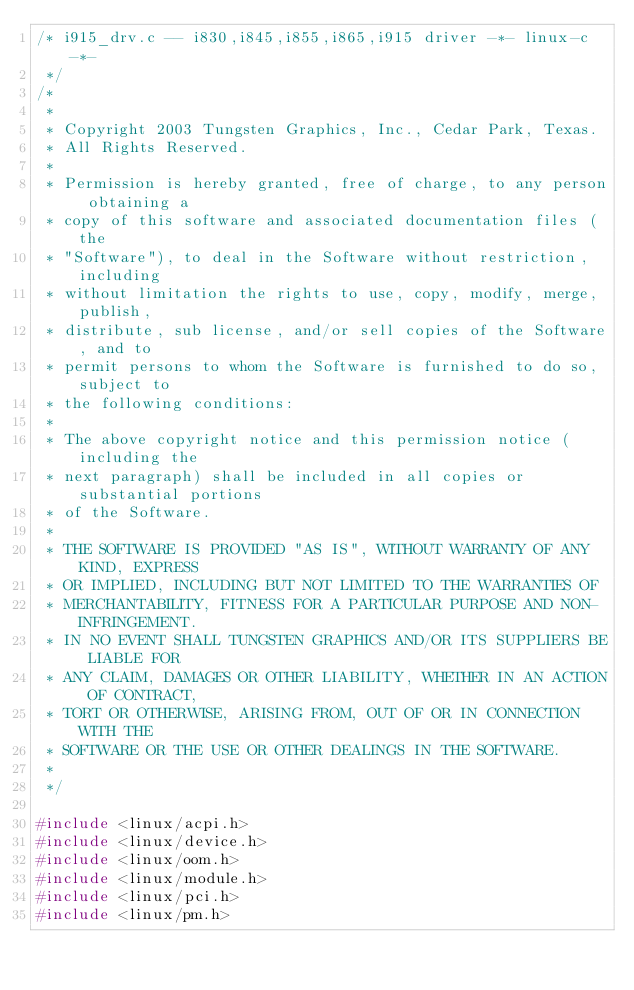Convert code to text. <code><loc_0><loc_0><loc_500><loc_500><_C_>/* i915_drv.c -- i830,i845,i855,i865,i915 driver -*- linux-c -*-
 */
/*
 *
 * Copyright 2003 Tungsten Graphics, Inc., Cedar Park, Texas.
 * All Rights Reserved.
 *
 * Permission is hereby granted, free of charge, to any person obtaining a
 * copy of this software and associated documentation files (the
 * "Software"), to deal in the Software without restriction, including
 * without limitation the rights to use, copy, modify, merge, publish,
 * distribute, sub license, and/or sell copies of the Software, and to
 * permit persons to whom the Software is furnished to do so, subject to
 * the following conditions:
 *
 * The above copyright notice and this permission notice (including the
 * next paragraph) shall be included in all copies or substantial portions
 * of the Software.
 *
 * THE SOFTWARE IS PROVIDED "AS IS", WITHOUT WARRANTY OF ANY KIND, EXPRESS
 * OR IMPLIED, INCLUDING BUT NOT LIMITED TO THE WARRANTIES OF
 * MERCHANTABILITY, FITNESS FOR A PARTICULAR PURPOSE AND NON-INFRINGEMENT.
 * IN NO EVENT SHALL TUNGSTEN GRAPHICS AND/OR ITS SUPPLIERS BE LIABLE FOR
 * ANY CLAIM, DAMAGES OR OTHER LIABILITY, WHETHER IN AN ACTION OF CONTRACT,
 * TORT OR OTHERWISE, ARISING FROM, OUT OF OR IN CONNECTION WITH THE
 * SOFTWARE OR THE USE OR OTHER DEALINGS IN THE SOFTWARE.
 *
 */

#include <linux/acpi.h>
#include <linux/device.h>
#include <linux/oom.h>
#include <linux/module.h>
#include <linux/pci.h>
#include <linux/pm.h></code> 